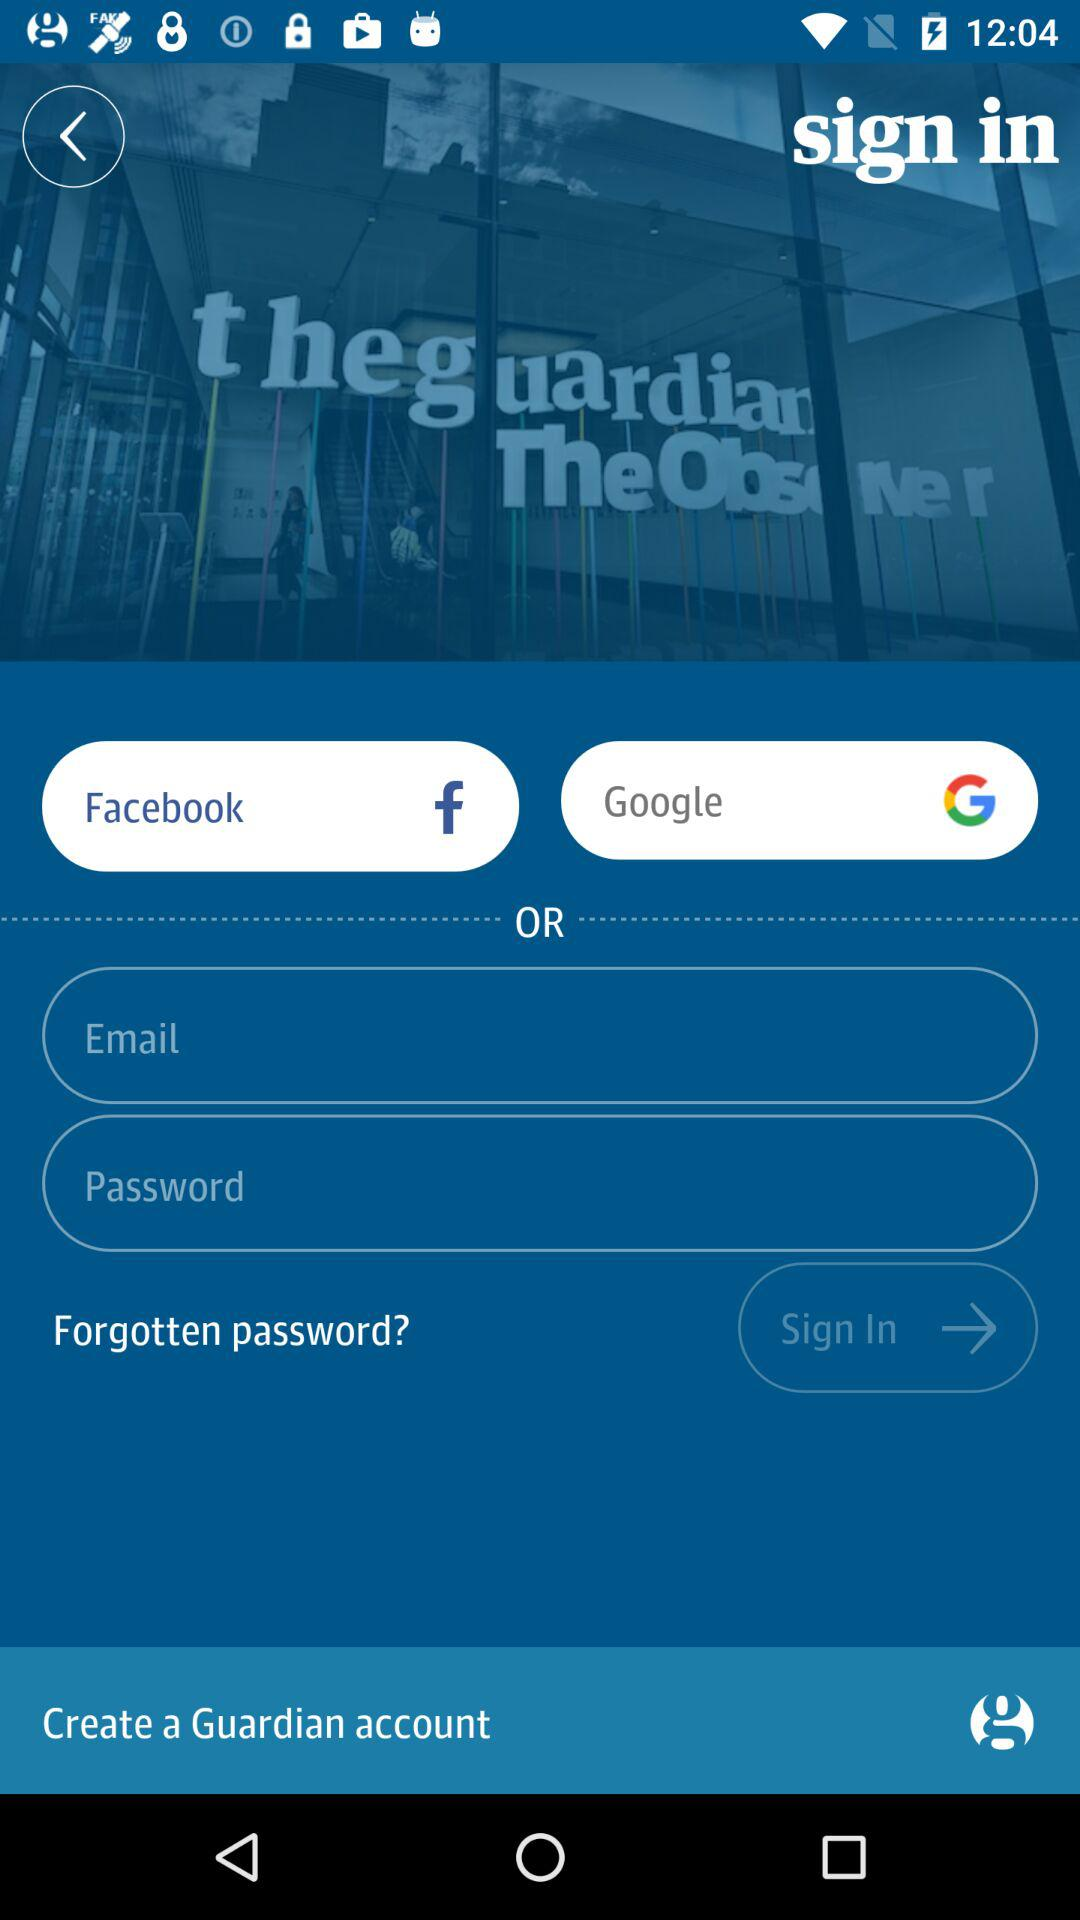What are the options given for sign-in? The options given for sign-in are "Facebook", "Google" and "Email". 